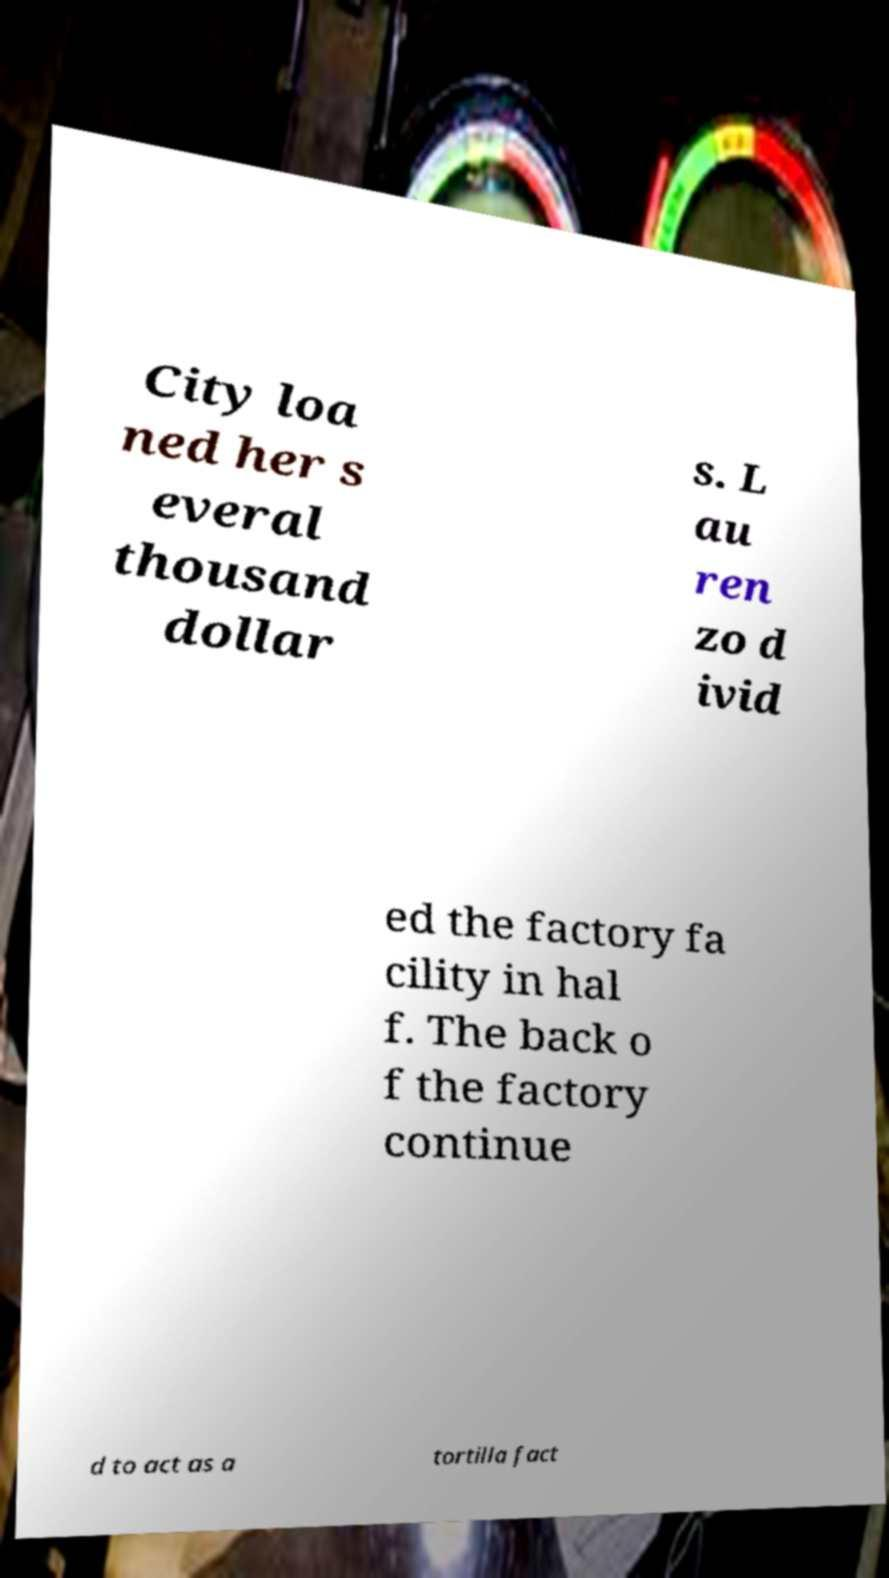Could you assist in decoding the text presented in this image and type it out clearly? City loa ned her s everal thousand dollar s. L au ren zo d ivid ed the factory fa cility in hal f. The back o f the factory continue d to act as a tortilla fact 